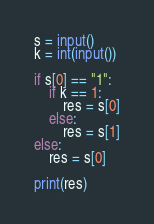<code> <loc_0><loc_0><loc_500><loc_500><_Python_>s = input()
k = int(input())

if s[0] == "1":
    if k == 1:
        res = s[0]
    else:
        res = s[1]
else:
    res = s[0]

print(res)</code> 